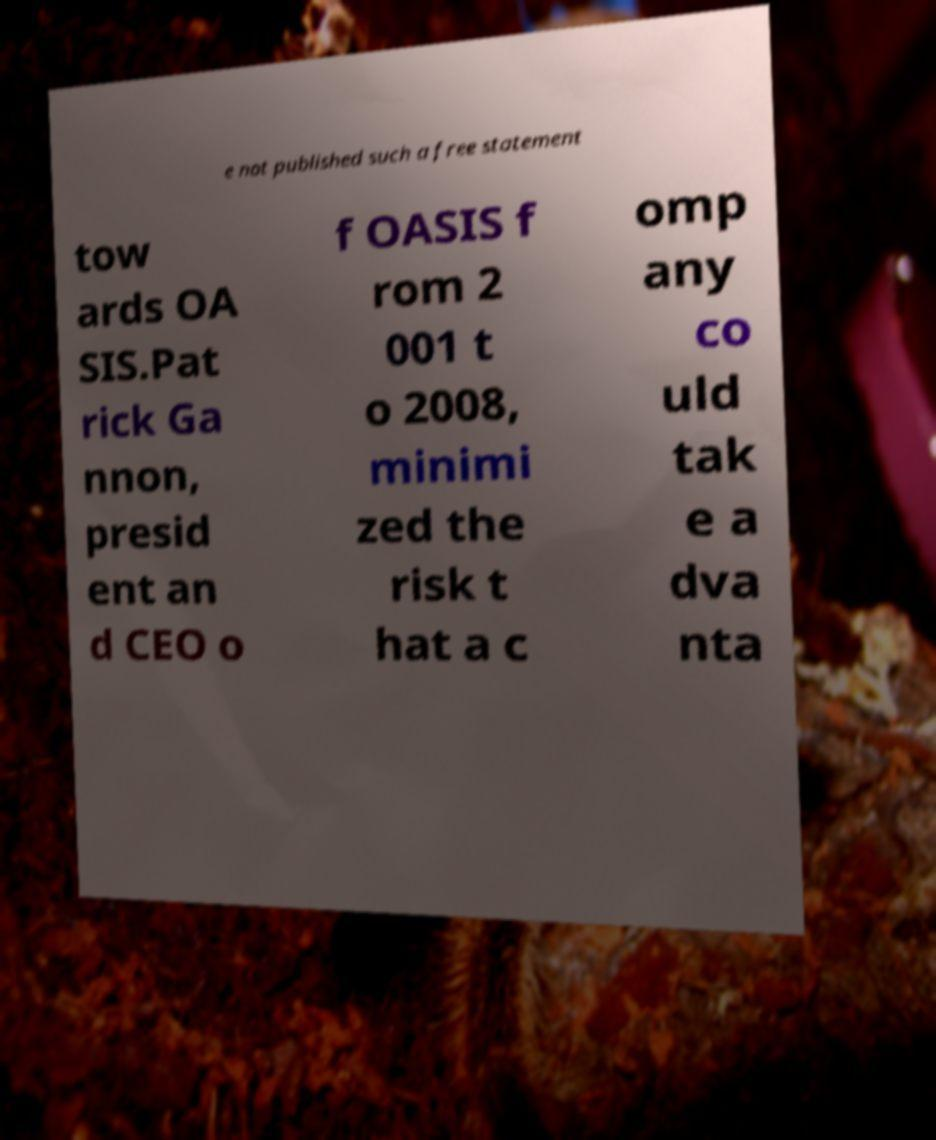I need the written content from this picture converted into text. Can you do that? e not published such a free statement tow ards OA SIS.Pat rick Ga nnon, presid ent an d CEO o f OASIS f rom 2 001 t o 2008, minimi zed the risk t hat a c omp any co uld tak e a dva nta 